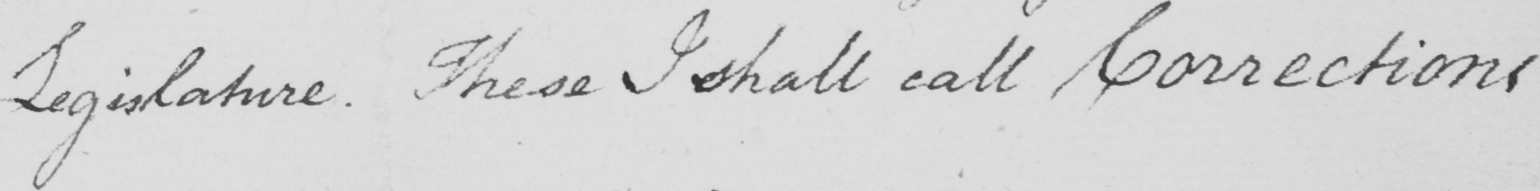Transcribe the text shown in this historical manuscript line. Legislature . These I shall call Corrections 